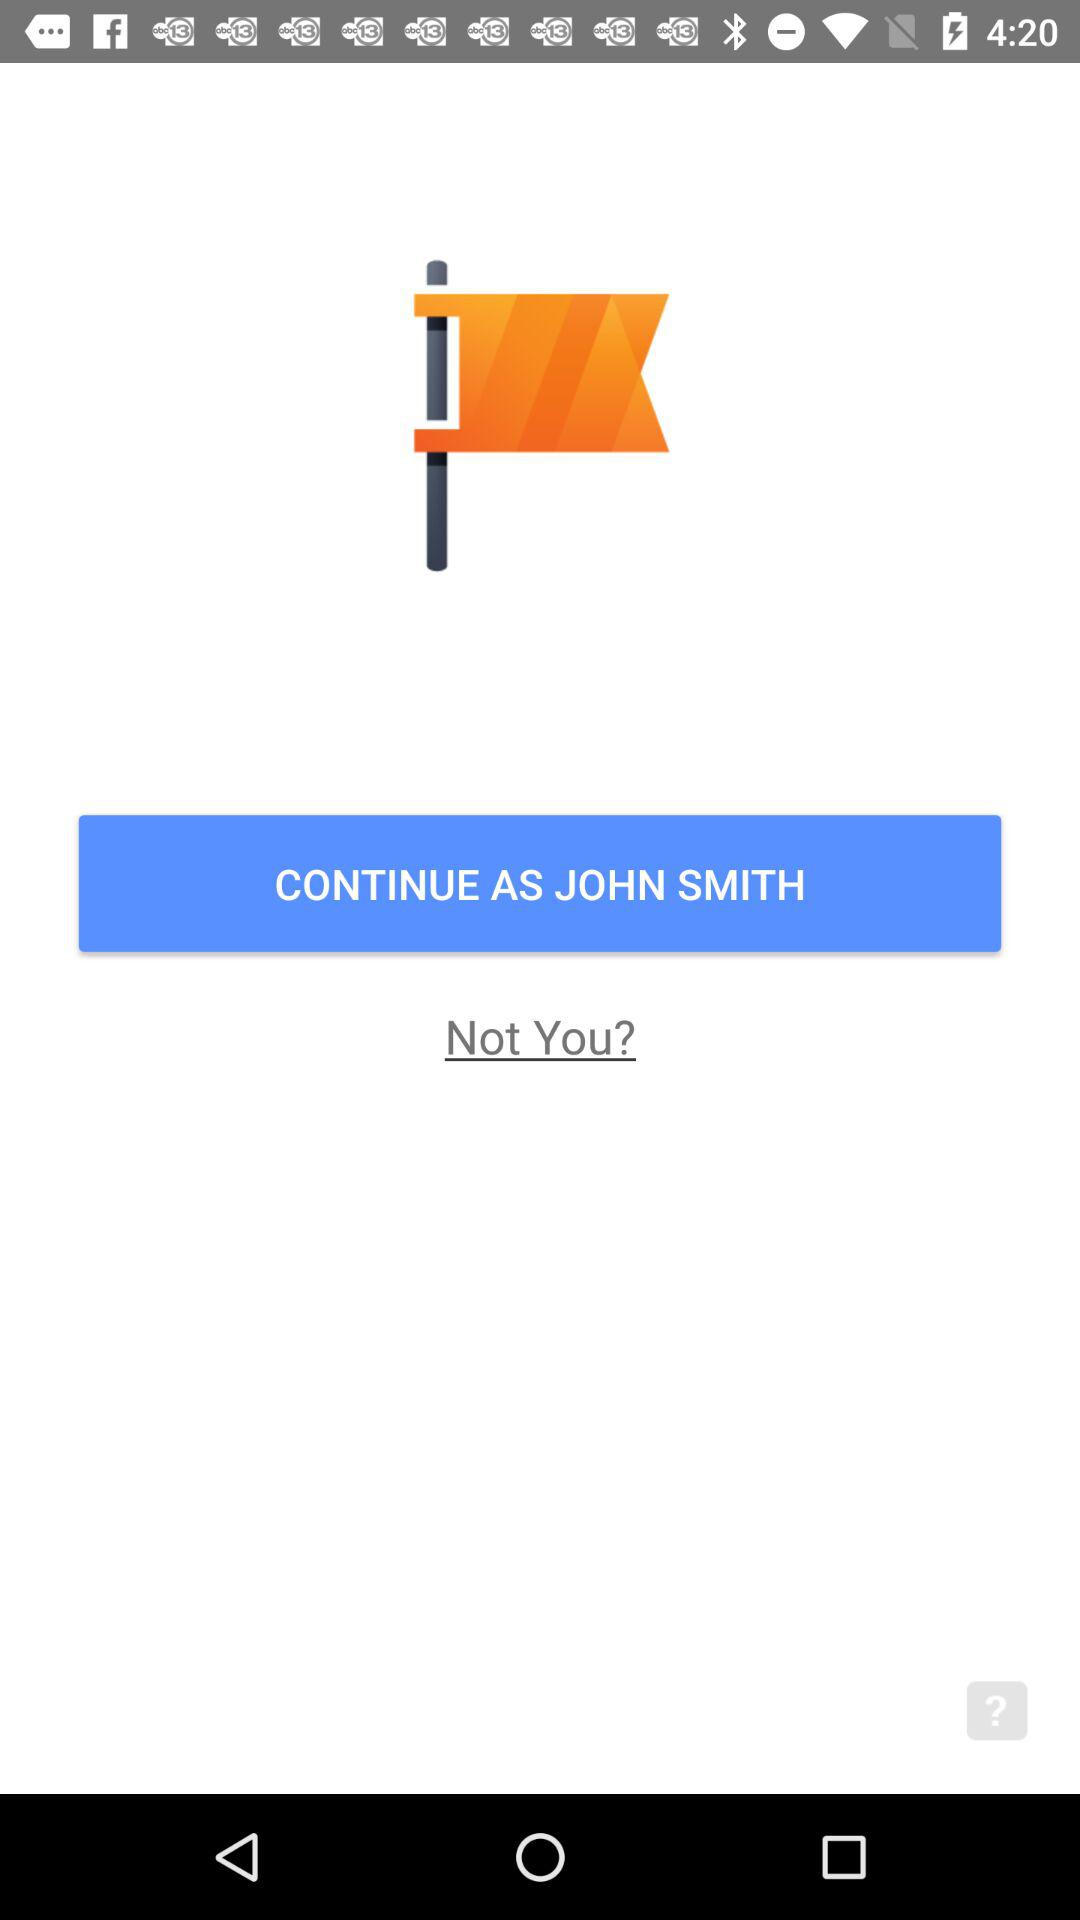What is the user name? The user name is John Smith. 